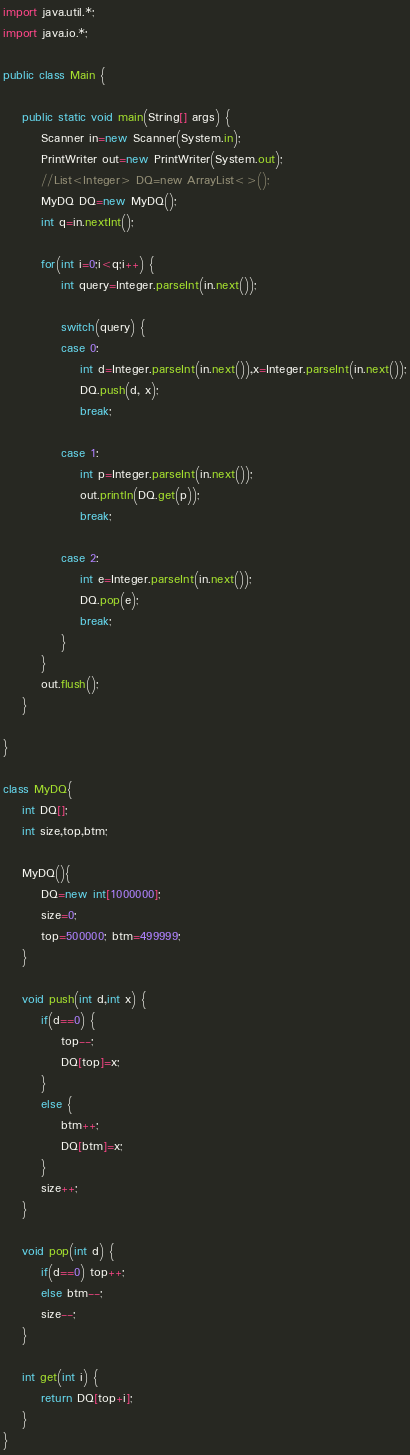Convert code to text. <code><loc_0><loc_0><loc_500><loc_500><_Java_>import java.util.*;
import java.io.*;

public class Main {

	public static void main(String[] args) {
		Scanner in=new Scanner(System.in);
		PrintWriter out=new PrintWriter(System.out);
		//List<Integer> DQ=new ArrayList<>();
		MyDQ DQ=new MyDQ();
		int q=in.nextInt();
		
		for(int i=0;i<q;i++) {
			int query=Integer.parseInt(in.next());
			
			switch(query) {
			case 0:
				int d=Integer.parseInt(in.next()),x=Integer.parseInt(in.next());
				DQ.push(d, x);
				break;
				
			case 1:
				int p=Integer.parseInt(in.next());
				out.println(DQ.get(p));
				break;
				
			case 2:
				int e=Integer.parseInt(in.next());
				DQ.pop(e);
				break;
			}
		}
		out.flush();
	}

}

class MyDQ{
	int DQ[];
	int size,top,btm;
	
	MyDQ(){
		DQ=new int[1000000];
		size=0;
		top=500000; btm=499999;
	}
	
	void push(int d,int x) {
		if(d==0) {
			top--;
			DQ[top]=x;
		}
		else {
			btm++;
			DQ[btm]=x;
		}
		size++;
	}
	
	void pop(int d) {
		if(d==0) top++;
		else btm--;
		size--;
	}
	
	int get(int i) {
		return DQ[top+i];
	}
}

</code> 